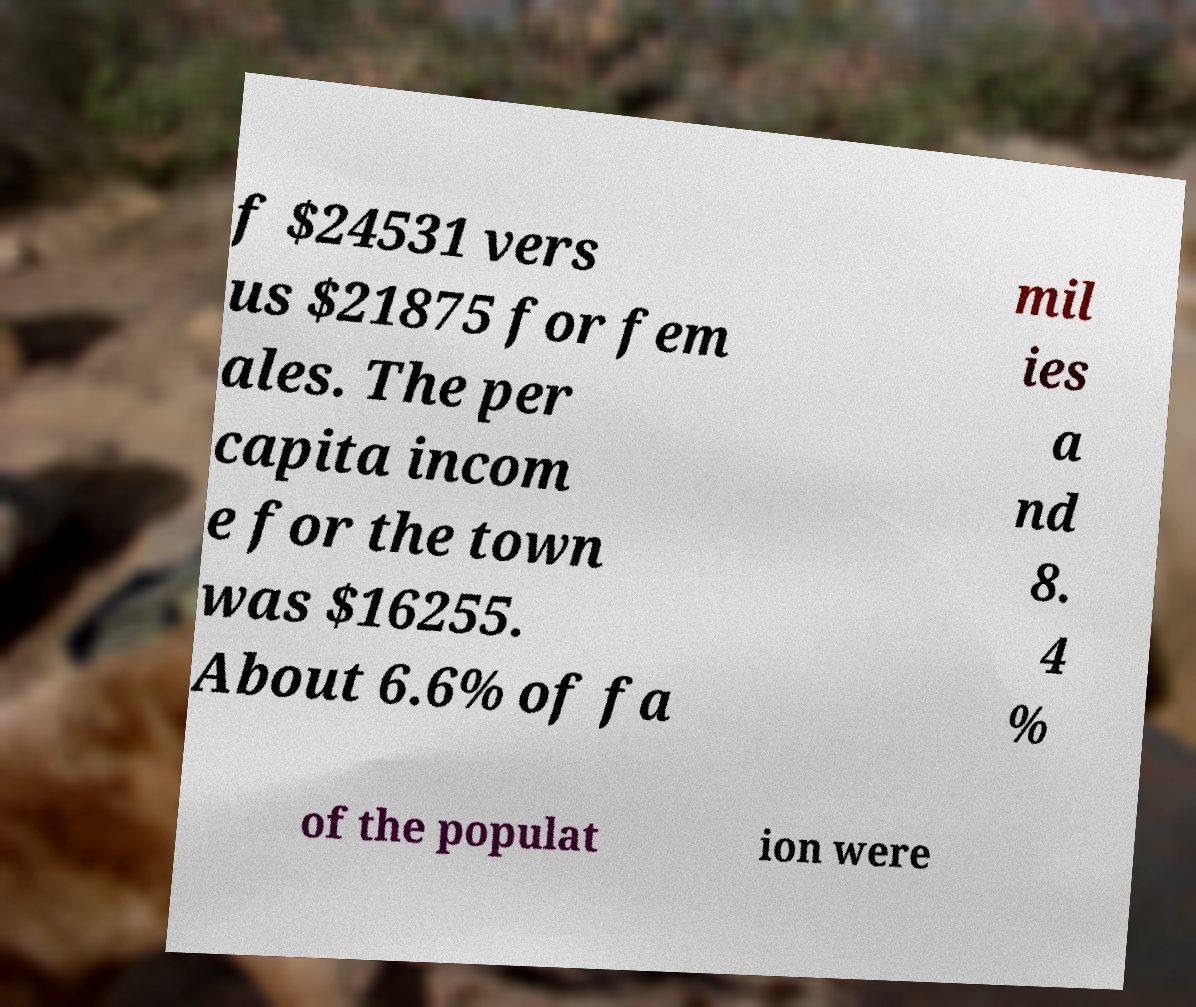Can you read and provide the text displayed in the image?This photo seems to have some interesting text. Can you extract and type it out for me? f $24531 vers us $21875 for fem ales. The per capita incom e for the town was $16255. About 6.6% of fa mil ies a nd 8. 4 % of the populat ion were 